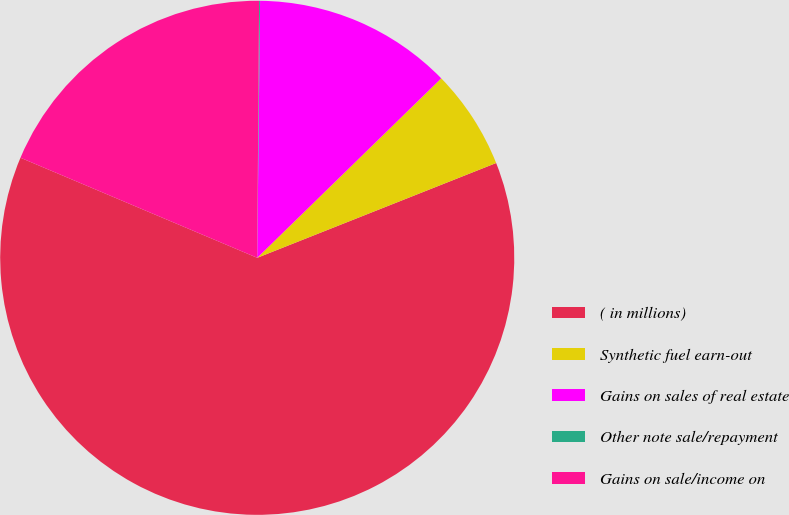Convert chart to OTSL. <chart><loc_0><loc_0><loc_500><loc_500><pie_chart><fcel>( in millions)<fcel>Synthetic fuel earn-out<fcel>Gains on sales of real estate<fcel>Other note sale/repayment<fcel>Gains on sale/income on<nl><fcel>62.37%<fcel>6.29%<fcel>12.52%<fcel>0.06%<fcel>18.75%<nl></chart> 